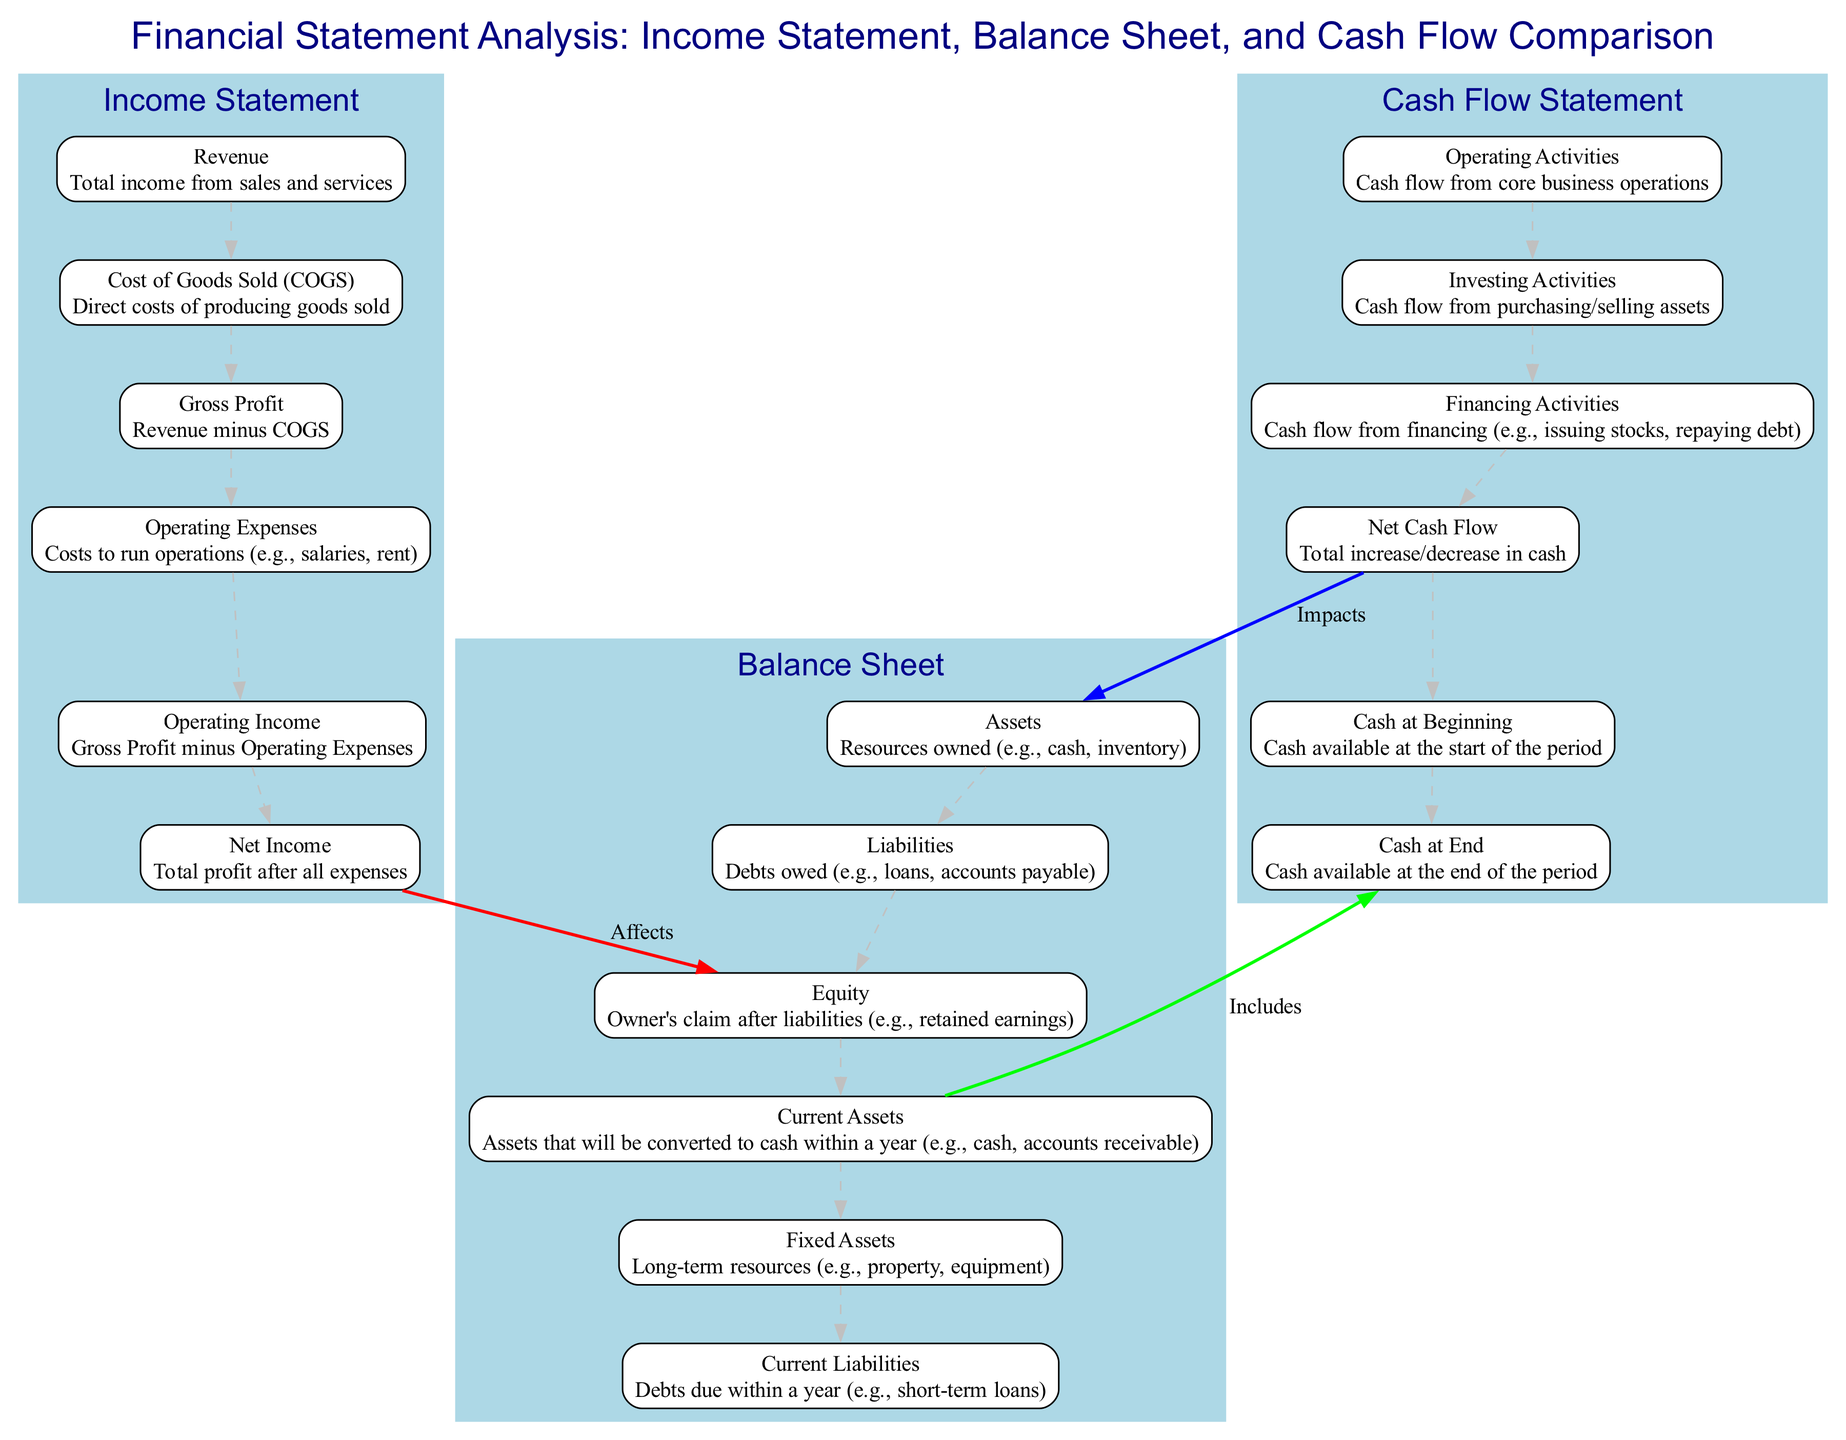What is the first element in the Income Statement? The diagram lists the elements in the Income Statement, starting with "Revenue" at the top.
Answer: Revenue How many elements are there in the Balance Sheet category? The Balance Sheet category has six elements: Assets, Liabilities, Equity, Current Assets, Fixed Assets, and Current Liabilities. Counting these gives a total of six.
Answer: 6 What does the arrow from Operating Income to Net Income represent? The arrow signifies a direct relationship where Operating Income is used to determine Net Income, showing that Net Income is calculated by subtracting other expenses from Operating Income.
Answer: Affects Which element in the Cash Flow Statement indicates cash at the start of the period? The Cash Flow Statement contains the node labeled "Cash at Beginning," which specifically represents the amount of cash available at the start of the period.
Answer: Cash at Beginning What is the relationship between Current Assets and Cash at End? The diagram shows that Current Assets directly influence "Cash at End," indicating that the current assets include cash that is available at the end of the period.
Answer: Includes How does Net Cash Flow connect to the Balance Sheet? The diagram illustrates that Net Cash Flow impacts the Assets section of the Balance Sheet, which implies that the net cash position can change the asset totals.
Answer: Impacts How many nodes are in the Cash Flow Statement? The Cash Flow Statement includes six nodes: Operating Activities, Investing Activities, Financing Activities, Net Cash Flow, Cash at Beginning, and Cash at End, resulting in a total of six nodes.
Answer: 6 What is the last element in the Income Statement? The last element in the Income Statement, as shown in the diagram, is "Net Income," indicating this is the final profit after all expenses have been accounted for.
Answer: Net Income What does the relationship from Balance Sheet Liabilities to Equity signify? The relationship indicates that Equity represents the owner's claim on the company's assets after all Liabilities have been paid off, demonstrating the financial structure.
Answer: Affects 